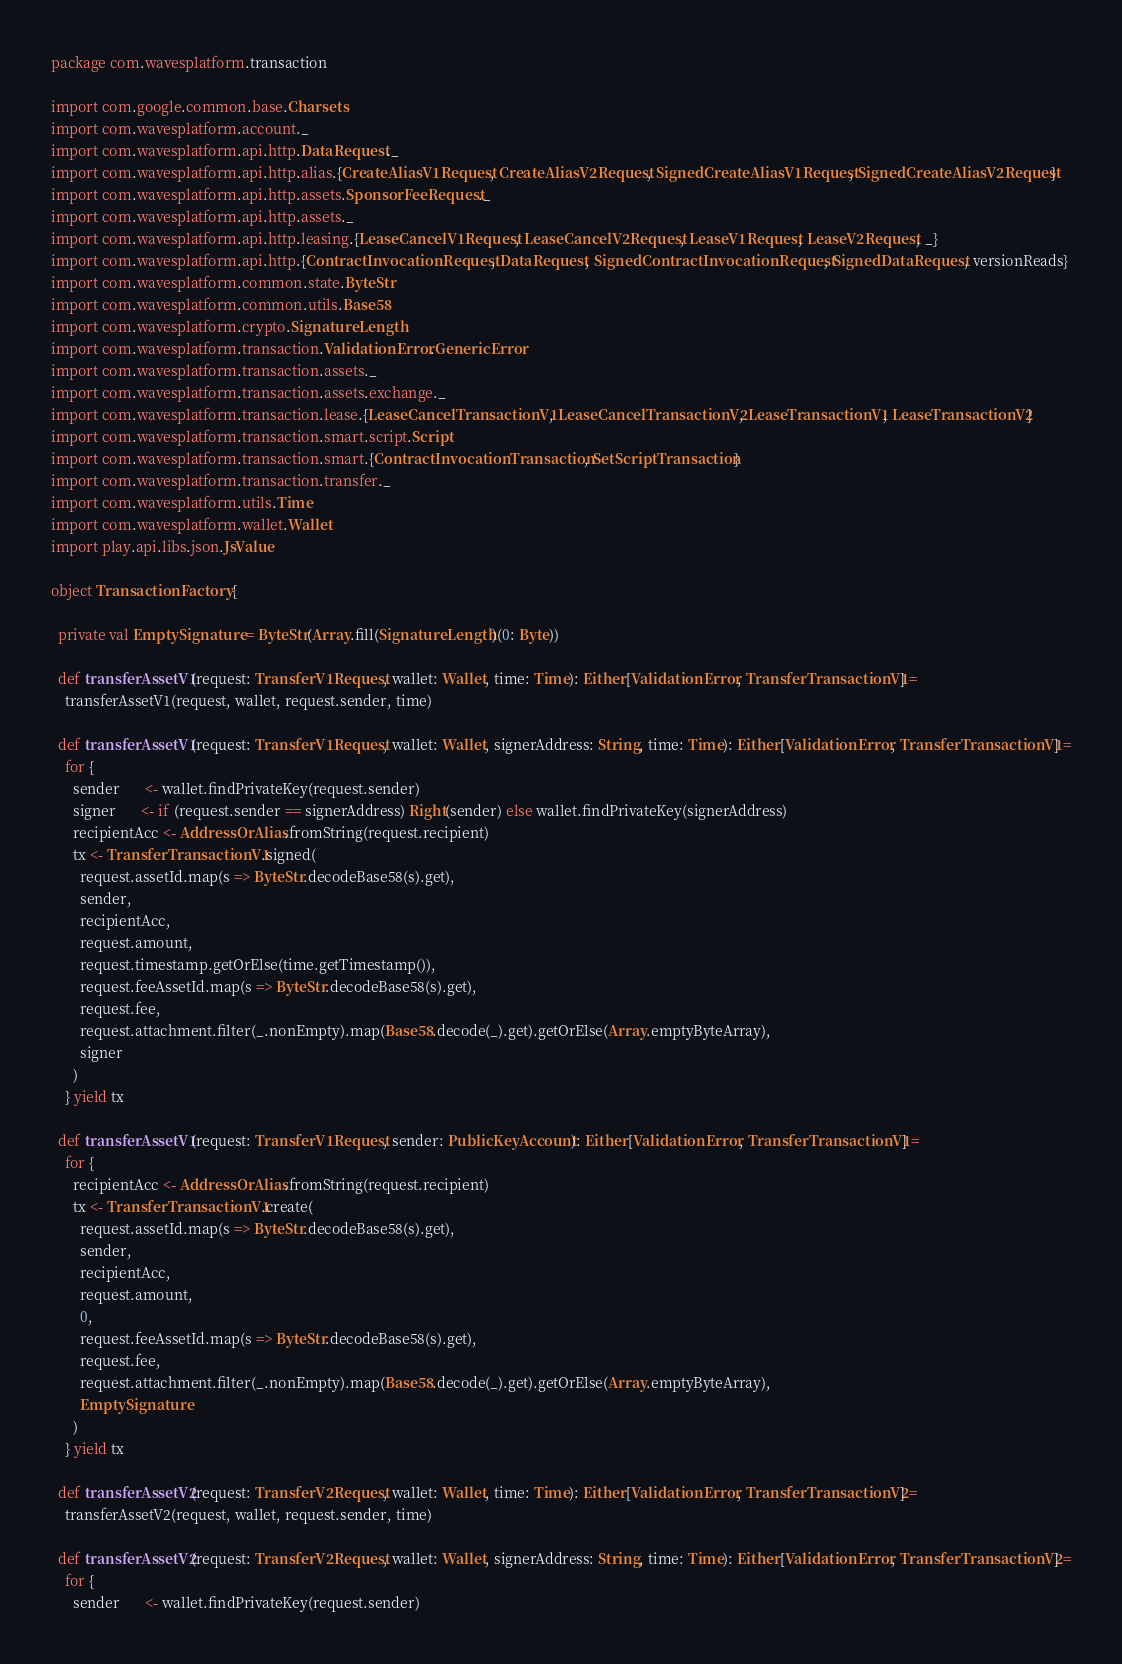<code> <loc_0><loc_0><loc_500><loc_500><_Scala_>package com.wavesplatform.transaction

import com.google.common.base.Charsets
import com.wavesplatform.account._
import com.wavesplatform.api.http.DataRequest._
import com.wavesplatform.api.http.alias.{CreateAliasV1Request, CreateAliasV2Request, SignedCreateAliasV1Request, SignedCreateAliasV2Request}
import com.wavesplatform.api.http.assets.SponsorFeeRequest._
import com.wavesplatform.api.http.assets._
import com.wavesplatform.api.http.leasing.{LeaseCancelV1Request, LeaseCancelV2Request, LeaseV1Request, LeaseV2Request, _}
import com.wavesplatform.api.http.{ContractInvocationRequest, DataRequest, SignedContractInvocationRequest, SignedDataRequest, versionReads}
import com.wavesplatform.common.state.ByteStr
import com.wavesplatform.common.utils.Base58
import com.wavesplatform.crypto.SignatureLength
import com.wavesplatform.transaction.ValidationError.GenericError
import com.wavesplatform.transaction.assets._
import com.wavesplatform.transaction.assets.exchange._
import com.wavesplatform.transaction.lease.{LeaseCancelTransactionV1, LeaseCancelTransactionV2, LeaseTransactionV1, LeaseTransactionV2}
import com.wavesplatform.transaction.smart.script.Script
import com.wavesplatform.transaction.smart.{ContractInvocationTransaction, SetScriptTransaction}
import com.wavesplatform.transaction.transfer._
import com.wavesplatform.utils.Time
import com.wavesplatform.wallet.Wallet
import play.api.libs.json.JsValue

object TransactionFactory {

  private val EmptySignature = ByteStr(Array.fill(SignatureLength)(0: Byte))

  def transferAssetV1(request: TransferV1Request, wallet: Wallet, time: Time): Either[ValidationError, TransferTransactionV1] =
    transferAssetV1(request, wallet, request.sender, time)

  def transferAssetV1(request: TransferV1Request, wallet: Wallet, signerAddress: String, time: Time): Either[ValidationError, TransferTransactionV1] =
    for {
      sender       <- wallet.findPrivateKey(request.sender)
      signer       <- if (request.sender == signerAddress) Right(sender) else wallet.findPrivateKey(signerAddress)
      recipientAcc <- AddressOrAlias.fromString(request.recipient)
      tx <- TransferTransactionV1.signed(
        request.assetId.map(s => ByteStr.decodeBase58(s).get),
        sender,
        recipientAcc,
        request.amount,
        request.timestamp.getOrElse(time.getTimestamp()),
        request.feeAssetId.map(s => ByteStr.decodeBase58(s).get),
        request.fee,
        request.attachment.filter(_.nonEmpty).map(Base58.decode(_).get).getOrElse(Array.emptyByteArray),
        signer
      )
    } yield tx

  def transferAssetV1(request: TransferV1Request, sender: PublicKeyAccount): Either[ValidationError, TransferTransactionV1] =
    for {
      recipientAcc <- AddressOrAlias.fromString(request.recipient)
      tx <- TransferTransactionV1.create(
        request.assetId.map(s => ByteStr.decodeBase58(s).get),
        sender,
        recipientAcc,
        request.amount,
        0,
        request.feeAssetId.map(s => ByteStr.decodeBase58(s).get),
        request.fee,
        request.attachment.filter(_.nonEmpty).map(Base58.decode(_).get).getOrElse(Array.emptyByteArray),
        EmptySignature
      )
    } yield tx

  def transferAssetV2(request: TransferV2Request, wallet: Wallet, time: Time): Either[ValidationError, TransferTransactionV2] =
    transferAssetV2(request, wallet, request.sender, time)

  def transferAssetV2(request: TransferV2Request, wallet: Wallet, signerAddress: String, time: Time): Either[ValidationError, TransferTransactionV2] =
    for {
      sender       <- wallet.findPrivateKey(request.sender)</code> 